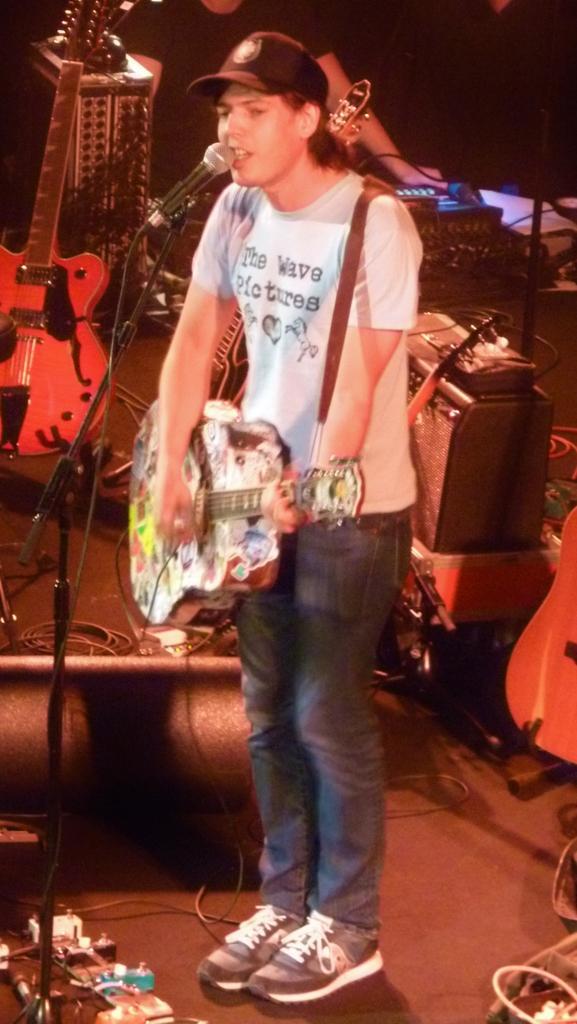Describe this image in one or two sentences. This is a picture of a man in white t shirt holding a guitar and singing a song in front of the man there is a microphone with stand. Behind the man there are some music systems. 